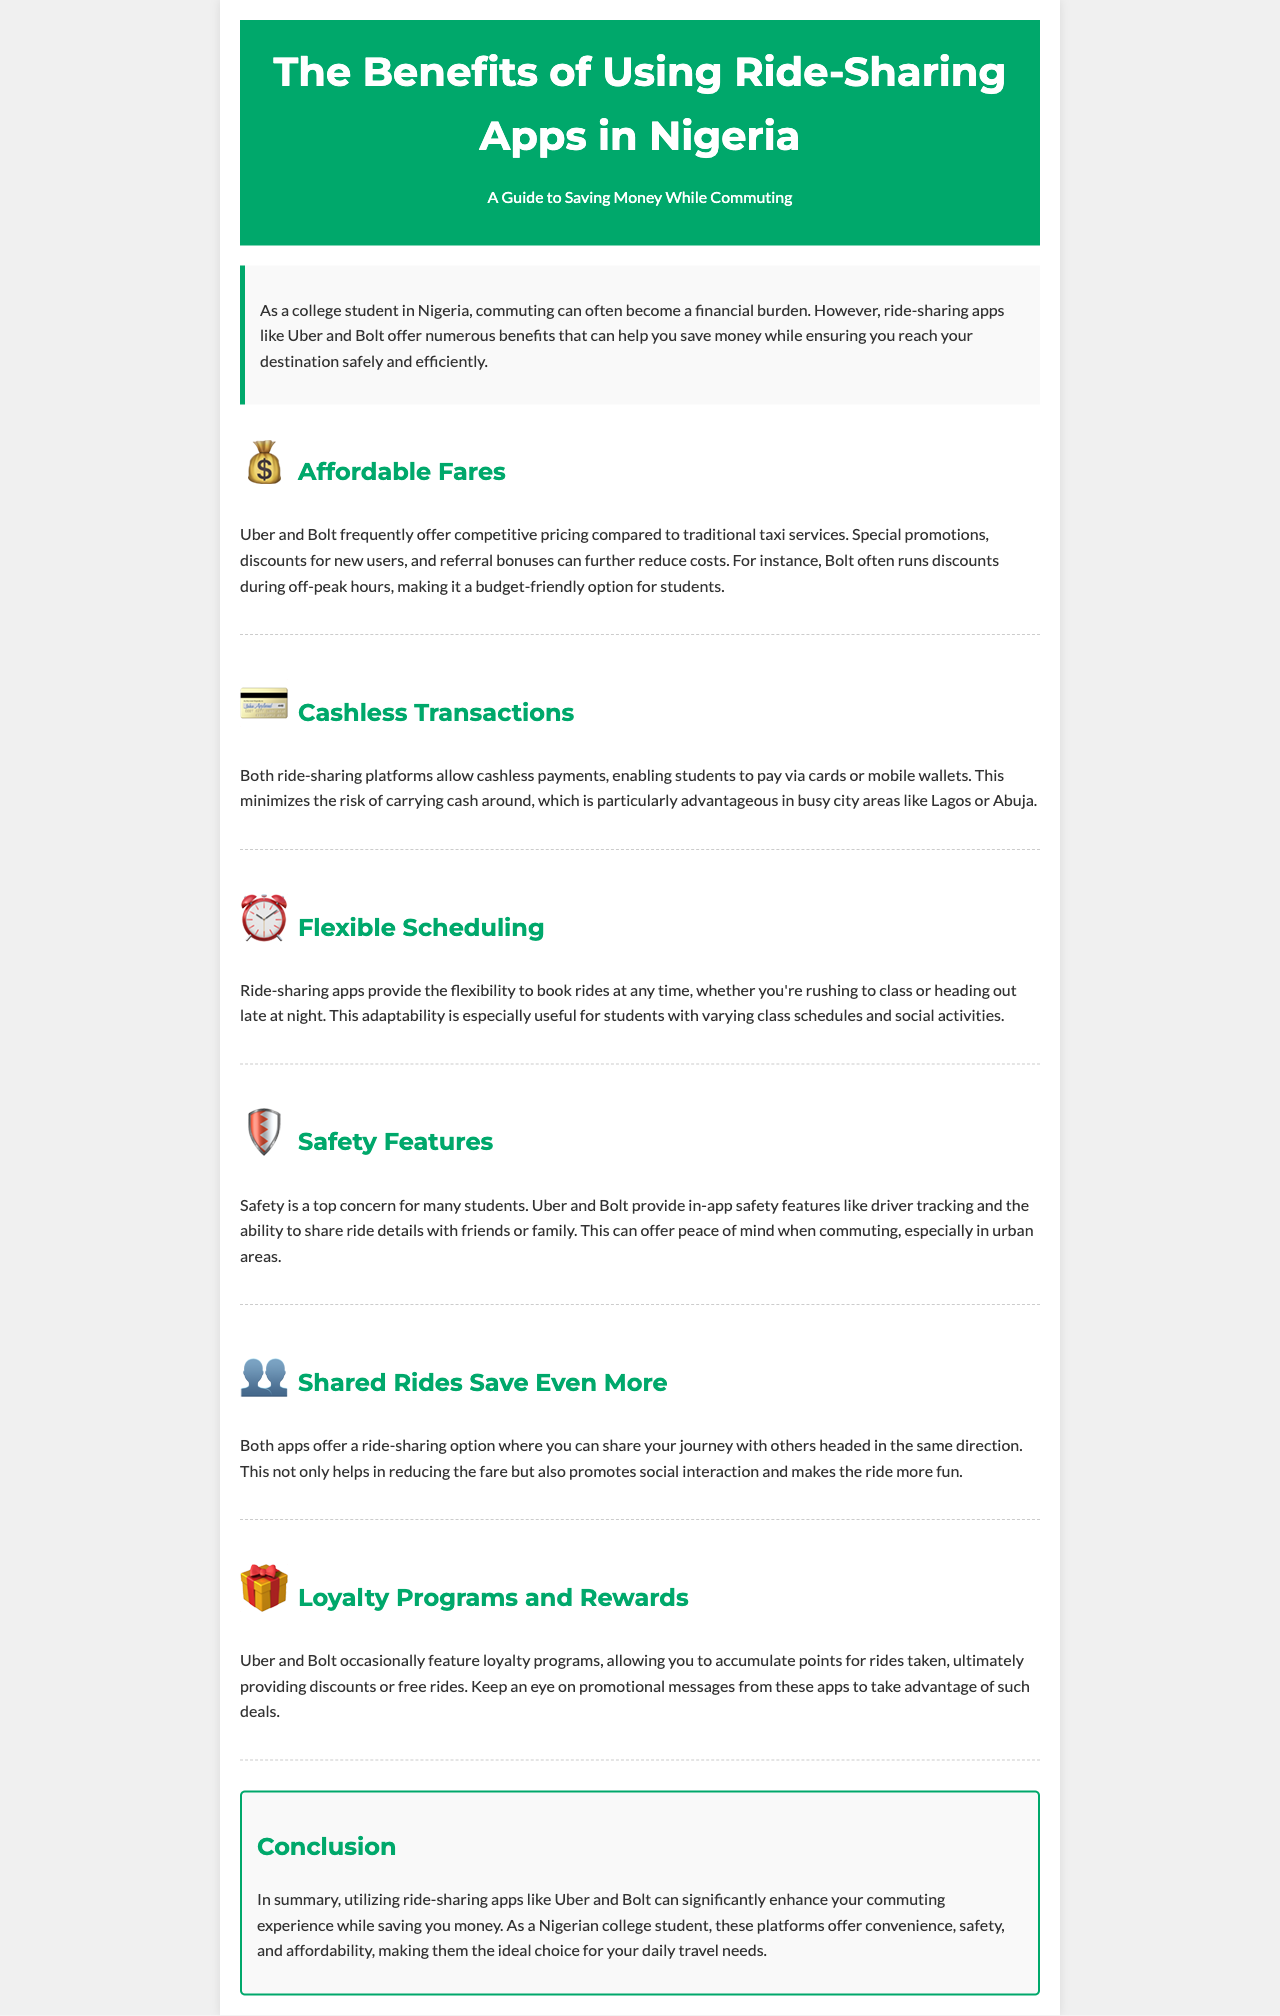What are two ride-sharing apps mentioned in the document? The document specifically mentions "Uber and Bolt" as the ride-sharing apps being discussed.
Answer: Uber and Bolt What is one advantage of using ride-sharing apps during off-peak hours? The document states that "Bolt often runs discounts during off-peak hours," indicating cost savings.
Answer: Discounts What feature allows cashless payments? The document describes that both apps enable "cashless payments" through cards or mobile wallets.
Answer: Cashless payments What is the purpose of loyalty programs mentioned? The document highlights "accumulate points for rides taken, ultimately providing discounts or free rides," which explains the reward system.
Answer: Discounts or free rides How do ride-sharing apps enhance safety for commuters? The document states that "Uber and Bolt provide in-app safety features like driver tracking," which helps ensure safety.
Answer: In-app safety features What aspect of ride-sharing apps is particularly useful for students? The document emphasizes "Flexible Scheduling" as a key benefit that accommodates varying schedules.
Answer: Flexible Scheduling What do ride-sharing apps offer that promotes social interaction? The document mentions that ride-sharing options allow users to "share your journey with others," which promotes social interaction.
Answer: Shared rides What is the conclusion drawn in the document about ride-sharing apps? The document concludes that ride-sharing apps "can significantly enhance your commuting experience while saving you money."
Answer: Save money 